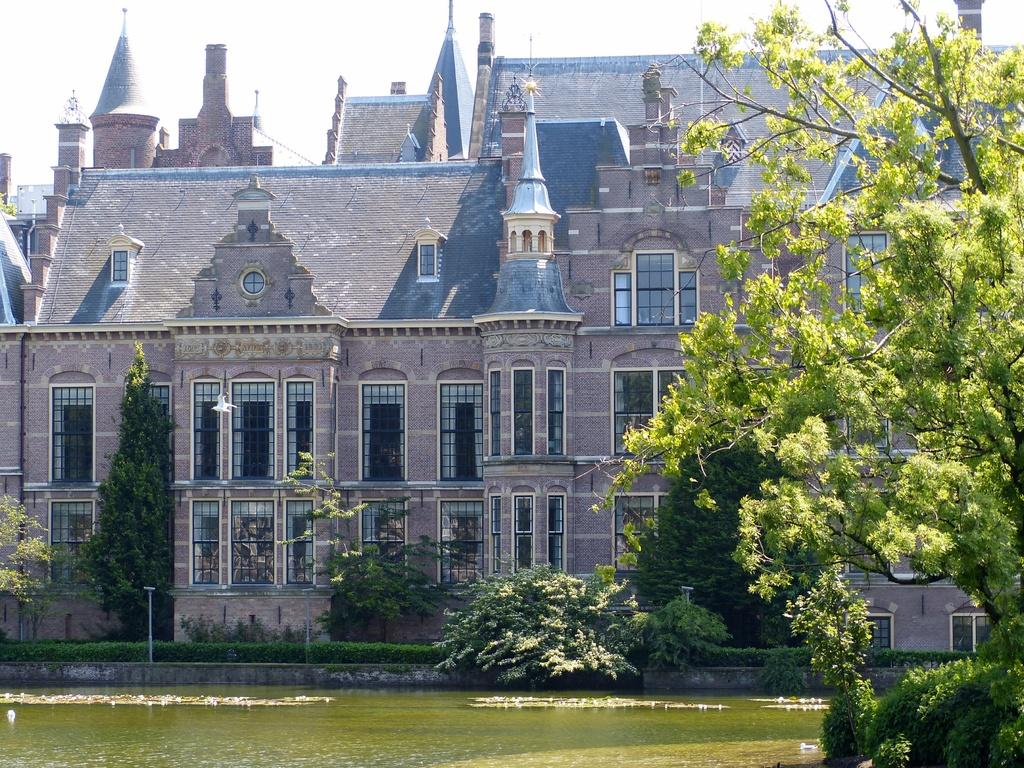What type of vegetation can be seen in the foreground of the image on the right side? There is greenery in the foreground of the image on the right side. What is visible at the bottom of the image? There is water visible at the bottom of the image. What can be seen in the middle of the image? There are trees and a building in the middle of the image. What is visible at the top of the image? The sky is visible at the top of the image. How many bears are sitting on the tray in the image? There are no bears or trays present in the image. What type of van is parked near the water in the image? There is no van present in the image; it features greenery, water, trees, a building, and the sky. 